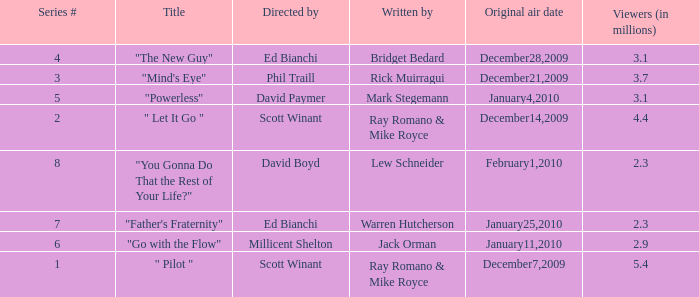How many viewers (in millions) did episode 1 have? 5.4. 